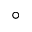Convert formula to latex. <formula><loc_0><loc_0><loc_500><loc_500>^ { \circ }</formula> 